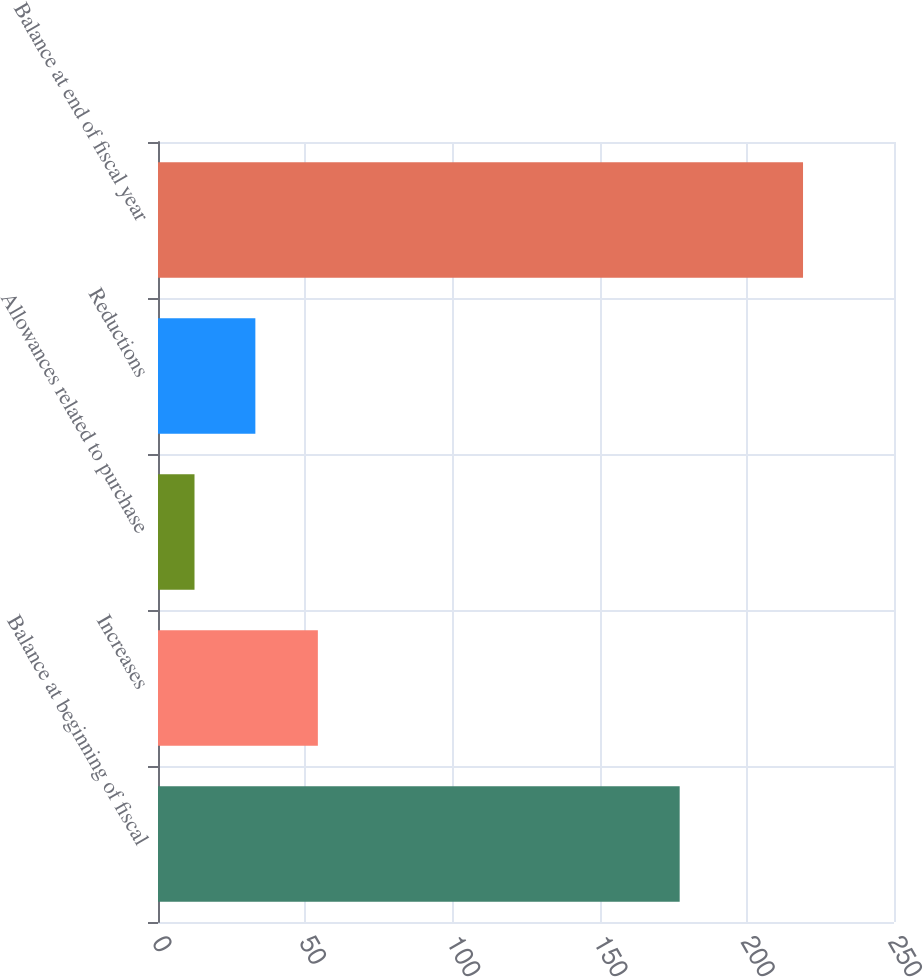Convert chart. <chart><loc_0><loc_0><loc_500><loc_500><bar_chart><fcel>Balance at beginning of fiscal<fcel>Increases<fcel>Allowances related to purchase<fcel>Reductions<fcel>Balance at end of fiscal year<nl><fcel>177.2<fcel>54.3<fcel>12.4<fcel>33.07<fcel>219.1<nl></chart> 